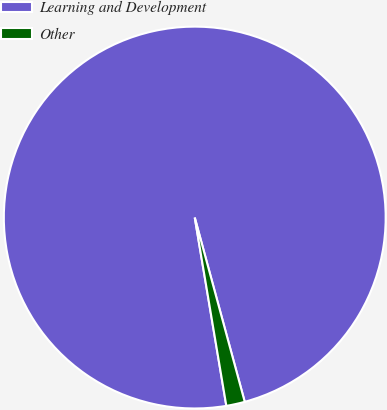Convert chart. <chart><loc_0><loc_0><loc_500><loc_500><pie_chart><fcel>Learning and Development<fcel>Other<nl><fcel>98.43%<fcel>1.57%<nl></chart> 